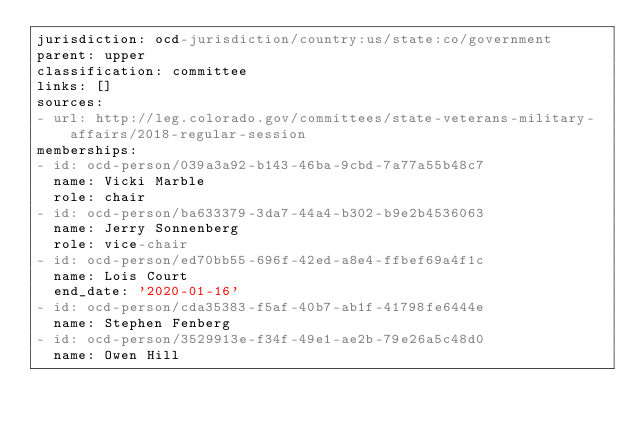Convert code to text. <code><loc_0><loc_0><loc_500><loc_500><_YAML_>jurisdiction: ocd-jurisdiction/country:us/state:co/government
parent: upper
classification: committee
links: []
sources:
- url: http://leg.colorado.gov/committees/state-veterans-military-affairs/2018-regular-session
memberships:
- id: ocd-person/039a3a92-b143-46ba-9cbd-7a77a55b48c7
  name: Vicki Marble
  role: chair
- id: ocd-person/ba633379-3da7-44a4-b302-b9e2b4536063
  name: Jerry Sonnenberg
  role: vice-chair
- id: ocd-person/ed70bb55-696f-42ed-a8e4-ffbef69a4f1c
  name: Lois Court
  end_date: '2020-01-16'
- id: ocd-person/cda35383-f5af-40b7-ab1f-41798fe6444e
  name: Stephen Fenberg
- id: ocd-person/3529913e-f34f-49e1-ae2b-79e26a5c48d0
  name: Owen Hill
</code> 